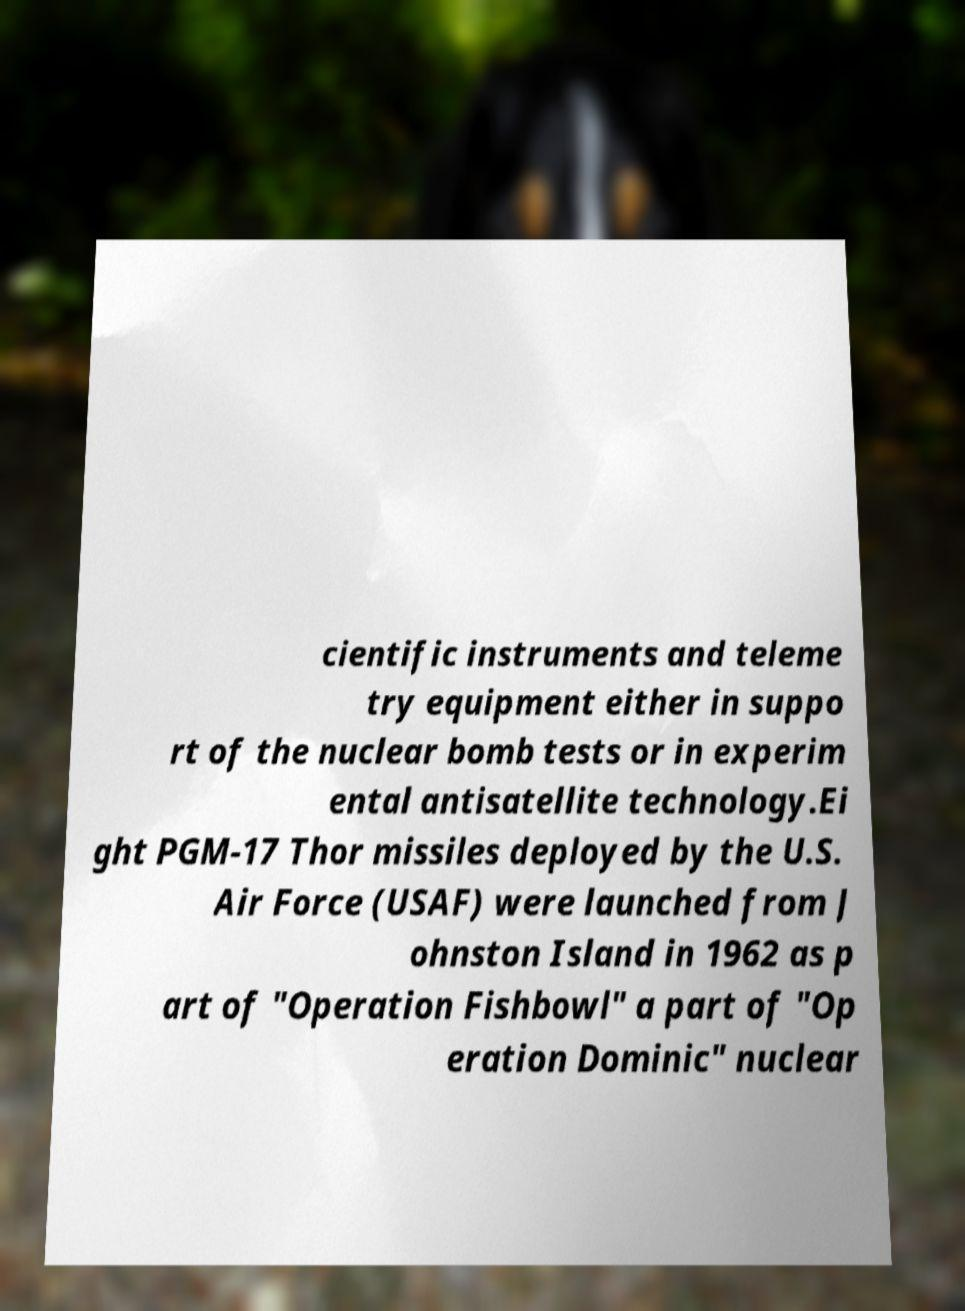What messages or text are displayed in this image? I need them in a readable, typed format. cientific instruments and teleme try equipment either in suppo rt of the nuclear bomb tests or in experim ental antisatellite technology.Ei ght PGM-17 Thor missiles deployed by the U.S. Air Force (USAF) were launched from J ohnston Island in 1962 as p art of "Operation Fishbowl" a part of "Op eration Dominic" nuclear 